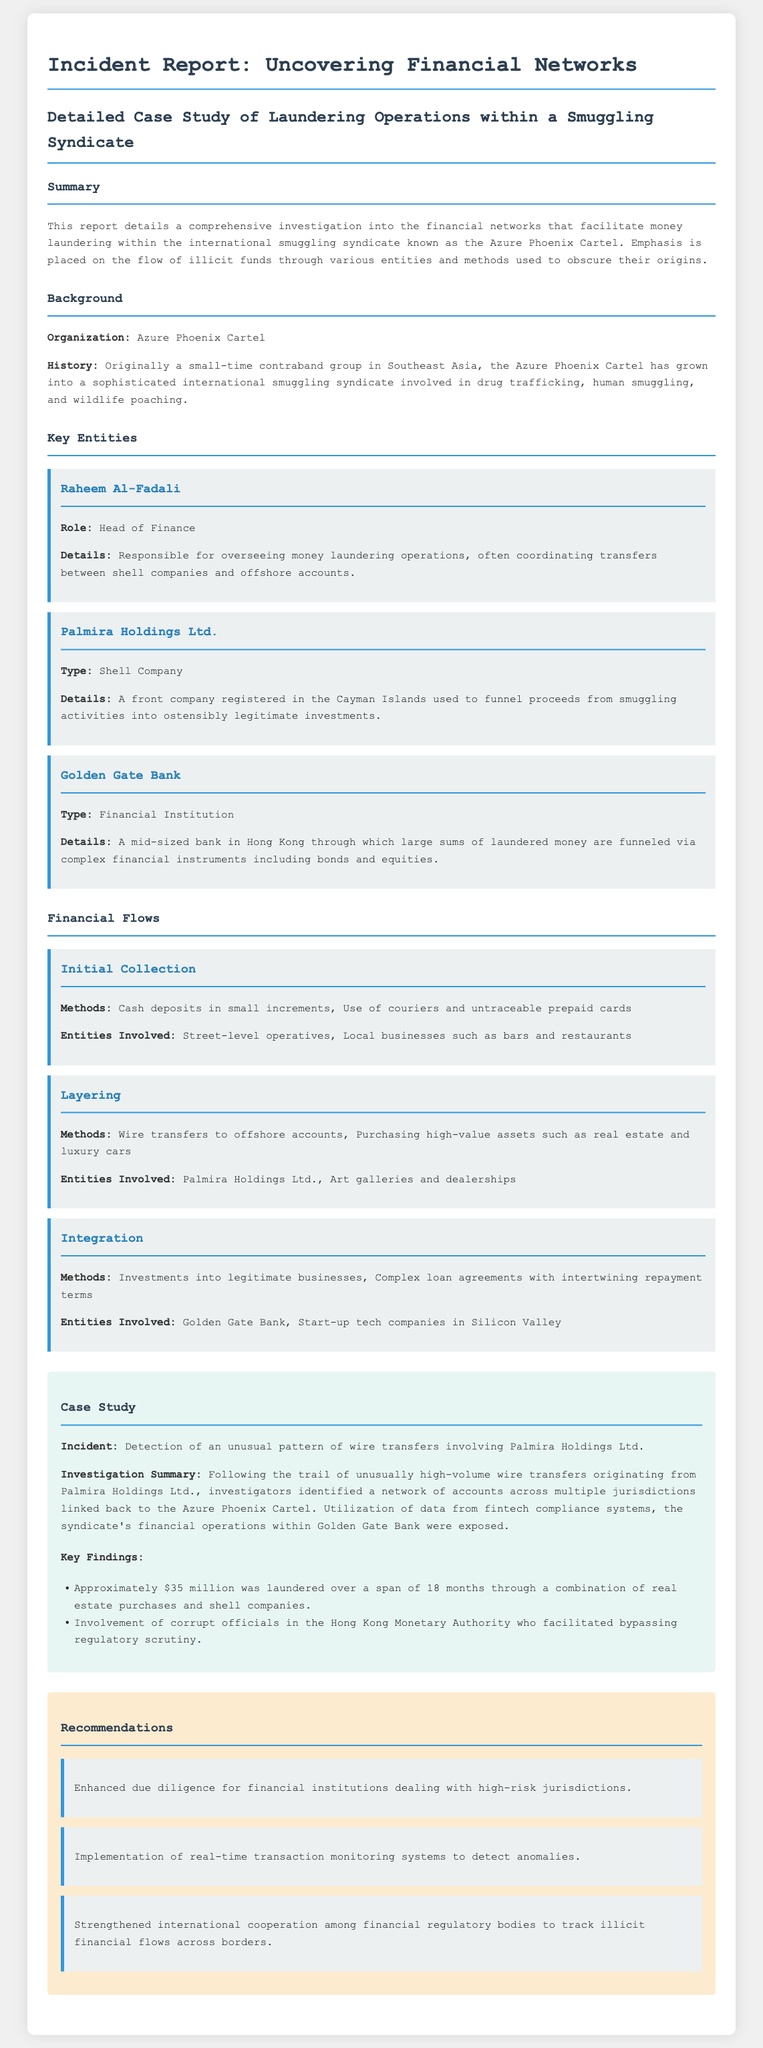What is the name of the smuggling syndicate? The document highlights the Azure Phoenix Cartel as the primary smuggling syndicate investigated.
Answer: Azure Phoenix Cartel Who is the head of finance for the Azure Phoenix Cartel? Raheem Al-Fadali is identified as the head of finance in the report.
Answer: Raheem Al-Fadali What type of company is Palmira Holdings Ltd.? The document classifies Palmira Holdings Ltd. as a shell company involved in laundering operations.
Answer: Shell Company How much money was laundered over 18 months? The investigation revealed that approximately $35 million was laundered through various operations.
Answer: $35 million What method was used for initial collection of funds? Cash deposits in small increments were one of the methods used in the initial collection stage.
Answer: Cash deposits What recommendation is made regarding financial institutions? The report suggests enhanced due diligence for financial institutions that deal with high-risk jurisdictions.
Answer: Enhanced due diligence What was a key finding related to officials at the Hong Kong Monetary Authority? The findings indicated involvement of corrupt officials who facilitated bypassing regulatory scrutiny.
Answer: Corrupt officials What segment details the laundering methods utilized? The financial flows section of the report covers the methods utilized for laundering.
Answer: Financial Flows 